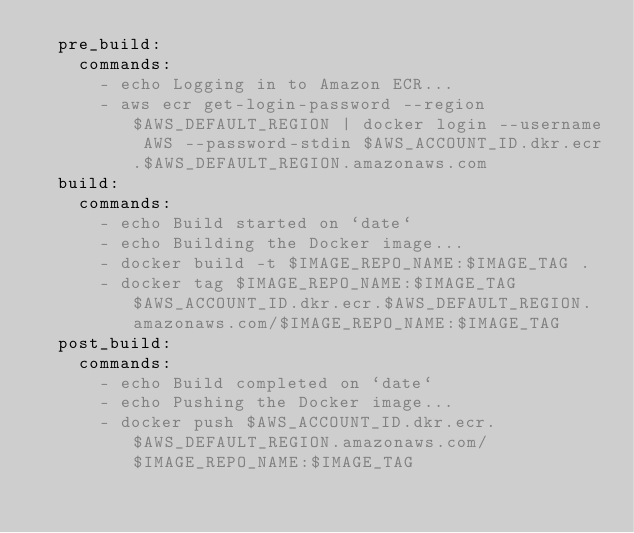<code> <loc_0><loc_0><loc_500><loc_500><_YAML_>  pre_build:
    commands:
      - echo Logging in to Amazon ECR...
      - aws ecr get-login-password --region $AWS_DEFAULT_REGION | docker login --username AWS --password-stdin $AWS_ACCOUNT_ID.dkr.ecr.$AWS_DEFAULT_REGION.amazonaws.com
  build:
    commands:
      - echo Build started on `date`
      - echo Building the Docker image...          
      - docker build -t $IMAGE_REPO_NAME:$IMAGE_TAG .
      - docker tag $IMAGE_REPO_NAME:$IMAGE_TAG $AWS_ACCOUNT_ID.dkr.ecr.$AWS_DEFAULT_REGION.amazonaws.com/$IMAGE_REPO_NAME:$IMAGE_TAG      
  post_build:
    commands:
      - echo Build completed on `date`
      - echo Pushing the Docker image...
      - docker push $AWS_ACCOUNT_ID.dkr.ecr.$AWS_DEFAULT_REGION.amazonaws.com/$IMAGE_REPO_NAME:$IMAGE_TAG</code> 